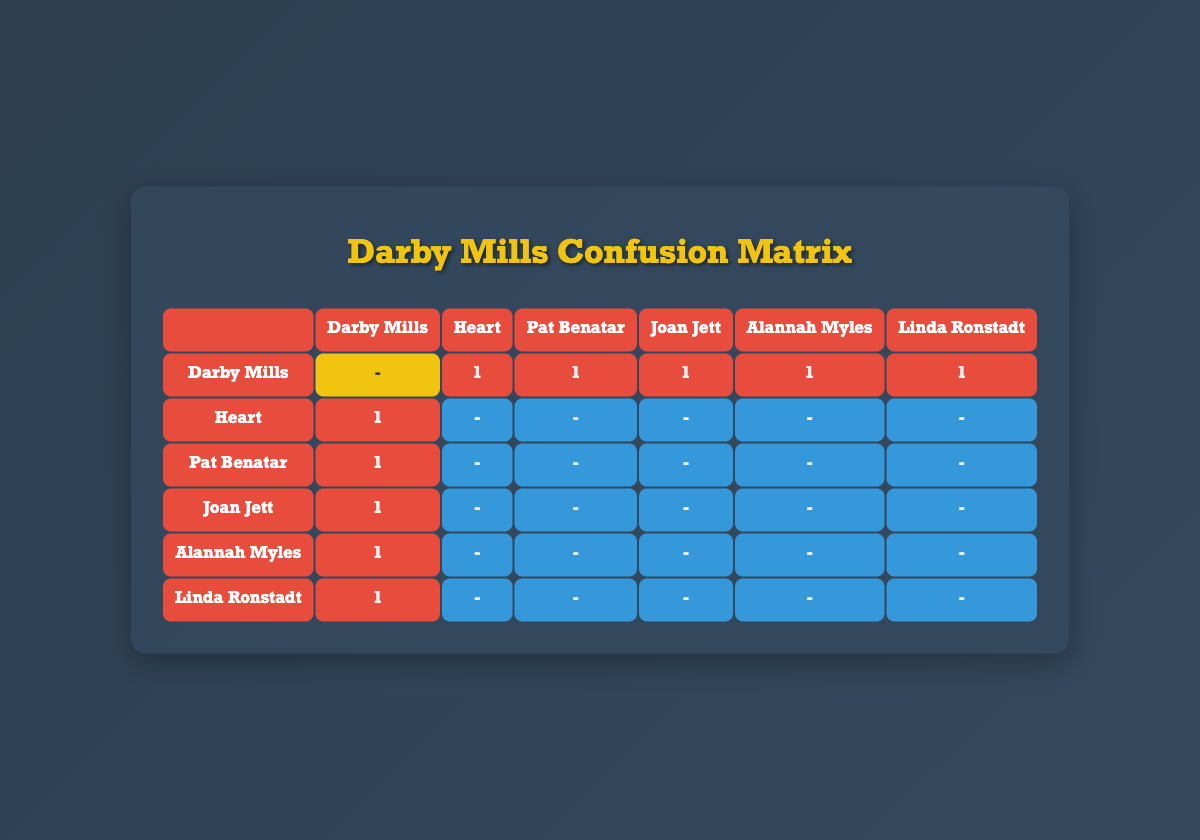What is the popularity score of Darby Mills' song "Never Forget"? The table lists the song "Never Forget" by Darby Mills with a popularity score of 85.
Answer: 85 How many songs by Darby Mills are listed in the table? The table features two songs by Darby Mills: "Never Forget" and "All the Time."
Answer: 2 Is there any song where Darby Mills was predicted correctly? According to the confusion matrix, there are no instances where Darby Mills was predicted correctly. All predictions for Darby Mills were incorrect.
Answer: No Which artist has the highest popularity score? Among the listed songs, Joan Jett's "I Love Rock 'n' Roll" has the highest popularity score of 91.
Answer: Joan Jett What percentage of predictions for Darby Mills' songs were incorrect? There are 5 incorrect predictions for Darby Mills out of 5 total predictions (each song has predictions for 5 other artists), resulting in a percentage of 100%.
Answer: 100% Among the similar artists, which song has a popularity above 88? Joan Jett's "I Love Rock 'n' Roll" (91) and Pat Benatar's "Hit Me With Your Best Shot" (88) both have popularity scores above 88.
Answer: Joan Jett and Pat Benatar Which two artists had predictions made for Darby Mills? The table shows that both Heart and Pat Benatar had predictions made for Darby Mills, which were incorrect.
Answer: Heart and Pat Benatar How many incorrect predictions were made for the song "Barracuda" by Heart? The confusion matrix indicates that there were no predictions made for the song "Barracuda." Therefore, the count of incorrect predictions is zero.
Answer: 0 What is the average popularity score of the artists listed in the confusion matrix? The total popularity of the songs involved is (85 + 90 + 88 + 91 + 89 + 84 + 82 + 87) = 512. There are 7 artists, so the average is 512/7 ≈ 73.14.
Answer: 73.14 